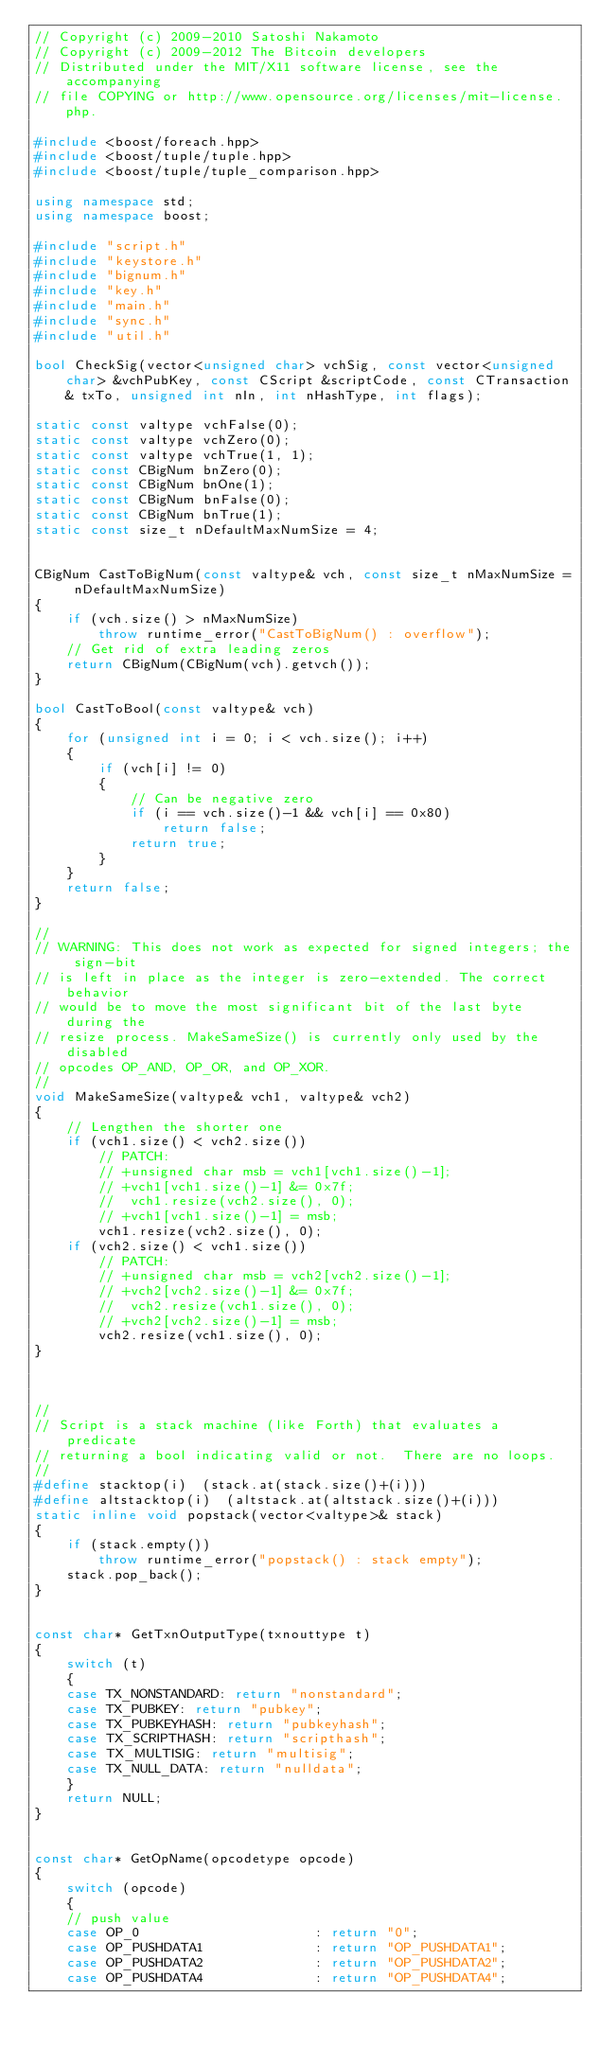Convert code to text. <code><loc_0><loc_0><loc_500><loc_500><_C++_>// Copyright (c) 2009-2010 Satoshi Nakamoto
// Copyright (c) 2009-2012 The Bitcoin developers
// Distributed under the MIT/X11 software license, see the accompanying
// file COPYING or http://www.opensource.org/licenses/mit-license.php.

#include <boost/foreach.hpp>
#include <boost/tuple/tuple.hpp>
#include <boost/tuple/tuple_comparison.hpp>

using namespace std;
using namespace boost;

#include "script.h"
#include "keystore.h"
#include "bignum.h"
#include "key.h"
#include "main.h"
#include "sync.h"
#include "util.h"

bool CheckSig(vector<unsigned char> vchSig, const vector<unsigned char> &vchPubKey, const CScript &scriptCode, const CTransaction& txTo, unsigned int nIn, int nHashType, int flags);

static const valtype vchFalse(0);
static const valtype vchZero(0);
static const valtype vchTrue(1, 1);
static const CBigNum bnZero(0);
static const CBigNum bnOne(1);
static const CBigNum bnFalse(0);
static const CBigNum bnTrue(1);
static const size_t nDefaultMaxNumSize = 4;


CBigNum CastToBigNum(const valtype& vch, const size_t nMaxNumSize = nDefaultMaxNumSize)
{
    if (vch.size() > nMaxNumSize)
        throw runtime_error("CastToBigNum() : overflow");
    // Get rid of extra leading zeros
    return CBigNum(CBigNum(vch).getvch());
}

bool CastToBool(const valtype& vch)
{
    for (unsigned int i = 0; i < vch.size(); i++)
    {
        if (vch[i] != 0)
        {
            // Can be negative zero
            if (i == vch.size()-1 && vch[i] == 0x80)
                return false;
            return true;
        }
    }
    return false;
}

//
// WARNING: This does not work as expected for signed integers; the sign-bit
// is left in place as the integer is zero-extended. The correct behavior
// would be to move the most significant bit of the last byte during the
// resize process. MakeSameSize() is currently only used by the disabled
// opcodes OP_AND, OP_OR, and OP_XOR.
//
void MakeSameSize(valtype& vch1, valtype& vch2)
{
    // Lengthen the shorter one
    if (vch1.size() < vch2.size())
        // PATCH:
        // +unsigned char msb = vch1[vch1.size()-1];
        // +vch1[vch1.size()-1] &= 0x7f;
        //  vch1.resize(vch2.size(), 0);
        // +vch1[vch1.size()-1] = msb;
        vch1.resize(vch2.size(), 0);
    if (vch2.size() < vch1.size())
        // PATCH:
        // +unsigned char msb = vch2[vch2.size()-1];
        // +vch2[vch2.size()-1] &= 0x7f;
        //  vch2.resize(vch1.size(), 0);
        // +vch2[vch2.size()-1] = msb;
        vch2.resize(vch1.size(), 0);
}



//
// Script is a stack machine (like Forth) that evaluates a predicate
// returning a bool indicating valid or not.  There are no loops.
//
#define stacktop(i)  (stack.at(stack.size()+(i)))
#define altstacktop(i)  (altstack.at(altstack.size()+(i)))
static inline void popstack(vector<valtype>& stack)
{
    if (stack.empty())
        throw runtime_error("popstack() : stack empty");
    stack.pop_back();
}


const char* GetTxnOutputType(txnouttype t)
{
    switch (t)
    {
    case TX_NONSTANDARD: return "nonstandard";
    case TX_PUBKEY: return "pubkey";
    case TX_PUBKEYHASH: return "pubkeyhash";
    case TX_SCRIPTHASH: return "scripthash";
    case TX_MULTISIG: return "multisig";
    case TX_NULL_DATA: return "nulldata";
    }
    return NULL;
}


const char* GetOpName(opcodetype opcode)
{
    switch (opcode)
    {
    // push value
    case OP_0                      : return "0";
    case OP_PUSHDATA1              : return "OP_PUSHDATA1";
    case OP_PUSHDATA2              : return "OP_PUSHDATA2";
    case OP_PUSHDATA4              : return "OP_PUSHDATA4";</code> 